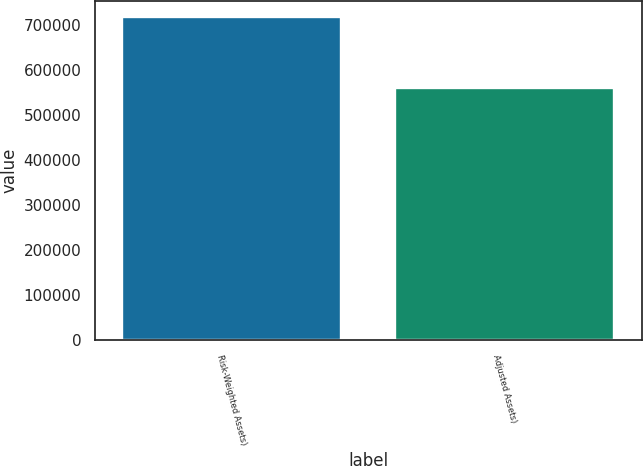<chart> <loc_0><loc_0><loc_500><loc_500><bar_chart><fcel>Risk-Weighted Assets)<fcel>Adjusted Assets)<nl><fcel>716441<fcel>560841<nl></chart> 